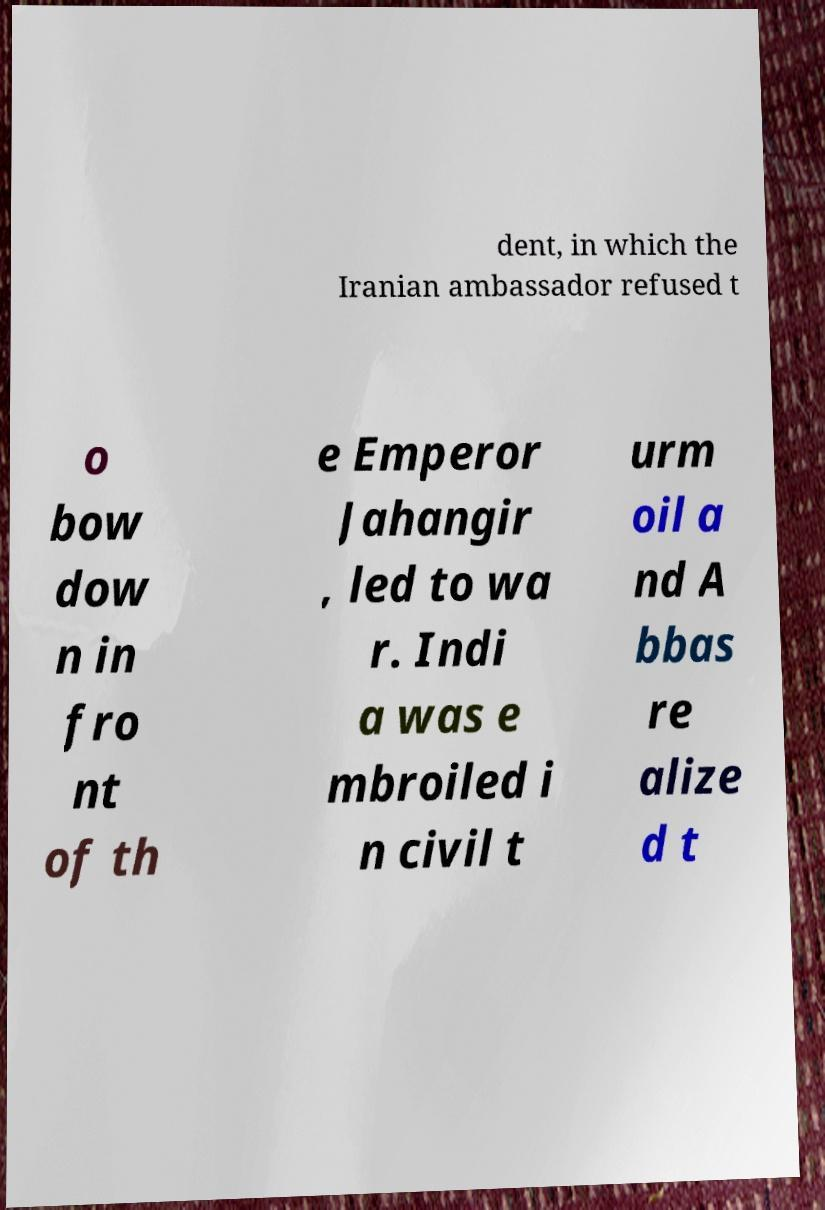I need the written content from this picture converted into text. Can you do that? dent, in which the Iranian ambassador refused t o bow dow n in fro nt of th e Emperor Jahangir , led to wa r. Indi a was e mbroiled i n civil t urm oil a nd A bbas re alize d t 